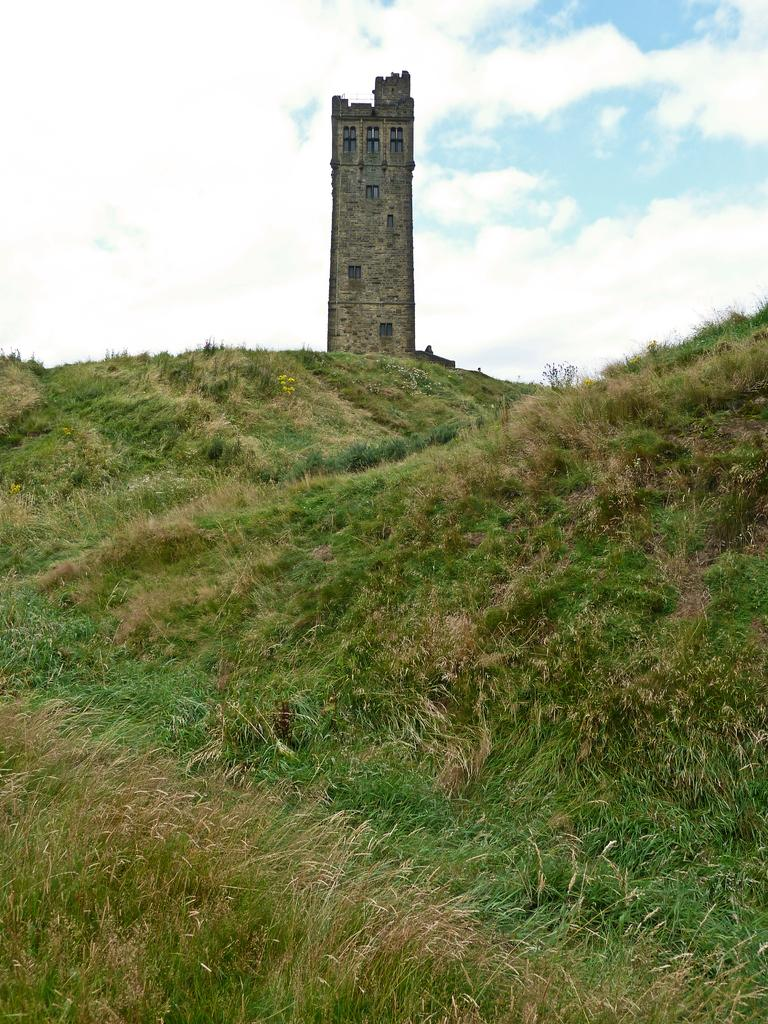What can be seen in the sky in the image? The sky with clouds is visible in the image. What structure is present in the image? There is a tower in the image. What feature does the tower have? The tower has windows. What type of vegetation is at the bottom of the image? Green grass is present at the bottom portion of the image. How many sticks are leaning against the tower in the image? There are no sticks present in the image. What type of creature can be seen hopping on the grass in the image? There is no creature, such as a toad, hopping on the grass in the image. 